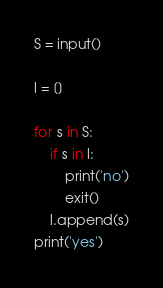<code> <loc_0><loc_0><loc_500><loc_500><_Python_>S = input()

l = []

for s in S:
    if s in l:
        print('no')
        exit()
    l.append(s)
print('yes')</code> 